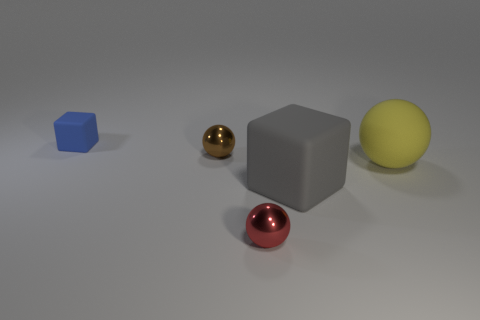Add 3 tiny balls. How many objects exist? 8 Subtract all balls. How many objects are left? 2 Add 2 large things. How many large things are left? 4 Add 3 metallic spheres. How many metallic spheres exist? 5 Subtract 0 purple cylinders. How many objects are left? 5 Subtract all red blocks. Subtract all big gray cubes. How many objects are left? 4 